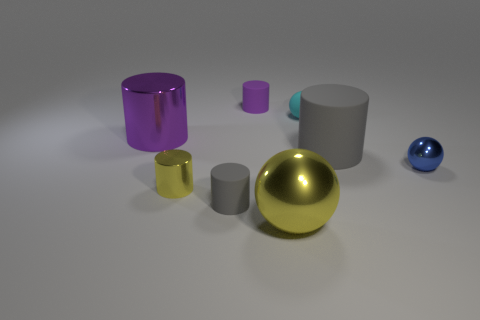The thing that is both in front of the cyan thing and behind the big gray cylinder has what shape?
Your answer should be compact. Cylinder. Do the gray thing that is to the right of the large ball and the yellow cylinder have the same material?
Give a very brief answer. No. How many objects are small cyan rubber spheres or metallic objects that are in front of the purple metallic cylinder?
Your response must be concise. 4. There is a sphere that is made of the same material as the tiny purple object; what is its color?
Ensure brevity in your answer.  Cyan. What number of large cylinders are made of the same material as the cyan object?
Offer a very short reply. 1. How many small green cylinders are there?
Your answer should be compact. 0. Does the metallic sphere that is in front of the small yellow thing have the same color as the small rubber object right of the small purple rubber object?
Provide a succinct answer. No. What number of purple matte cylinders are left of the large metallic ball?
Provide a succinct answer. 1. What material is the small thing that is the same color as the large rubber cylinder?
Your answer should be very brief. Rubber. Are there any large rubber objects of the same shape as the blue metal object?
Offer a very short reply. No. 